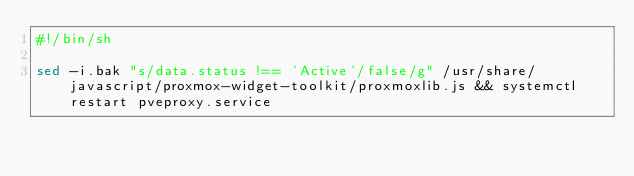Convert code to text. <code><loc_0><loc_0><loc_500><loc_500><_Bash_>#!/bin/sh

sed -i.bak "s/data.status !== 'Active'/false/g" /usr/share/javascript/proxmox-widget-toolkit/proxmoxlib.js && systemctl restart pveproxy.service
</code> 